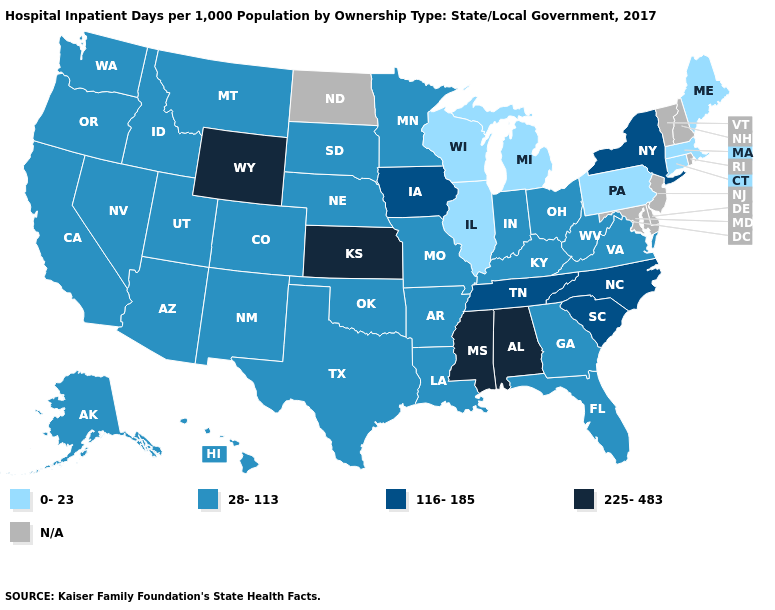Among the states that border Massachusetts , does New York have the lowest value?
Quick response, please. No. Name the states that have a value in the range 116-185?
Be succinct. Iowa, New York, North Carolina, South Carolina, Tennessee. Name the states that have a value in the range 28-113?
Be succinct. Alaska, Arizona, Arkansas, California, Colorado, Florida, Georgia, Hawaii, Idaho, Indiana, Kentucky, Louisiana, Minnesota, Missouri, Montana, Nebraska, Nevada, New Mexico, Ohio, Oklahoma, Oregon, South Dakota, Texas, Utah, Virginia, Washington, West Virginia. What is the value of Connecticut?
Give a very brief answer. 0-23. What is the lowest value in the USA?
Answer briefly. 0-23. What is the value of Montana?
Write a very short answer. 28-113. Does Arizona have the highest value in the USA?
Concise answer only. No. Among the states that border Wisconsin , does Michigan have the highest value?
Give a very brief answer. No. What is the value of West Virginia?
Concise answer only. 28-113. Which states have the highest value in the USA?
Answer briefly. Alabama, Kansas, Mississippi, Wyoming. What is the lowest value in states that border Utah?
Answer briefly. 28-113. Among the states that border Utah , does Wyoming have the highest value?
Keep it brief. Yes. What is the value of Nebraska?
Answer briefly. 28-113. Does Ohio have the highest value in the USA?
Write a very short answer. No. 